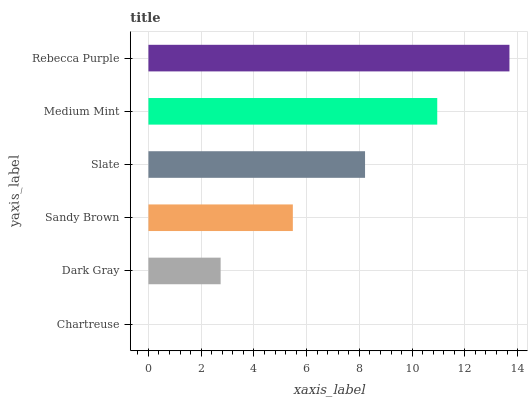Is Chartreuse the minimum?
Answer yes or no. Yes. Is Rebecca Purple the maximum?
Answer yes or no. Yes. Is Dark Gray the minimum?
Answer yes or no. No. Is Dark Gray the maximum?
Answer yes or no. No. Is Dark Gray greater than Chartreuse?
Answer yes or no. Yes. Is Chartreuse less than Dark Gray?
Answer yes or no. Yes. Is Chartreuse greater than Dark Gray?
Answer yes or no. No. Is Dark Gray less than Chartreuse?
Answer yes or no. No. Is Slate the high median?
Answer yes or no. Yes. Is Sandy Brown the low median?
Answer yes or no. Yes. Is Chartreuse the high median?
Answer yes or no. No. Is Medium Mint the low median?
Answer yes or no. No. 